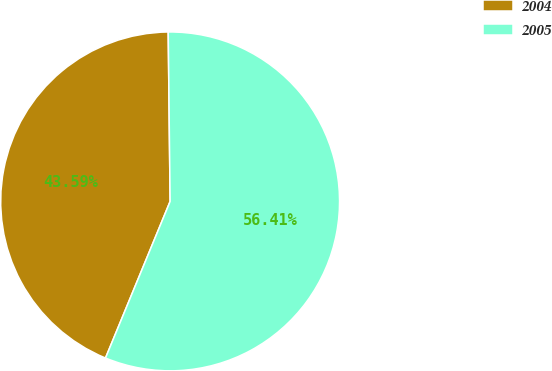Convert chart to OTSL. <chart><loc_0><loc_0><loc_500><loc_500><pie_chart><fcel>2004<fcel>2005<nl><fcel>43.59%<fcel>56.41%<nl></chart> 